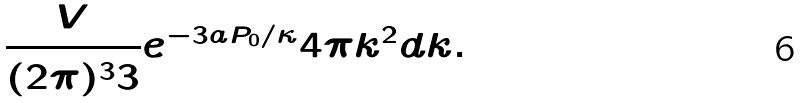<formula> <loc_0><loc_0><loc_500><loc_500>\frac { V } { ( 2 \pi ) ^ { 3 } { 3 } } e ^ { - 3 a P _ { 0 } / \kappa } 4 \pi k ^ { 2 } d k .</formula> 